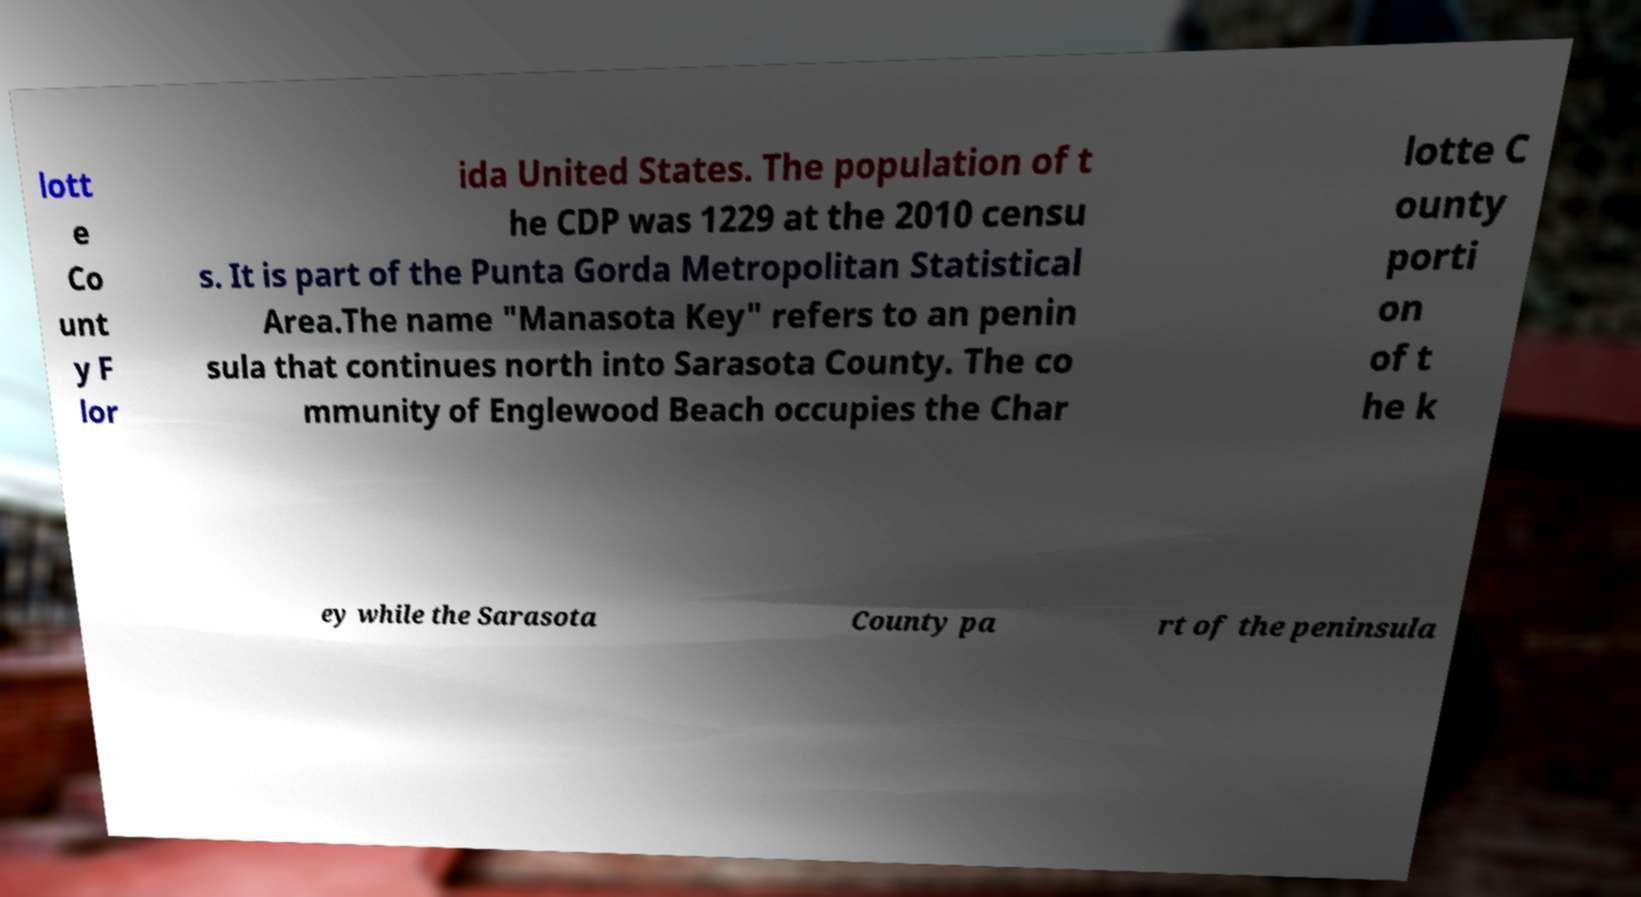Please identify and transcribe the text found in this image. lott e Co unt y F lor ida United States. The population of t he CDP was 1229 at the 2010 censu s. It is part of the Punta Gorda Metropolitan Statistical Area.The name "Manasota Key" refers to an penin sula that continues north into Sarasota County. The co mmunity of Englewood Beach occupies the Char lotte C ounty porti on of t he k ey while the Sarasota County pa rt of the peninsula 